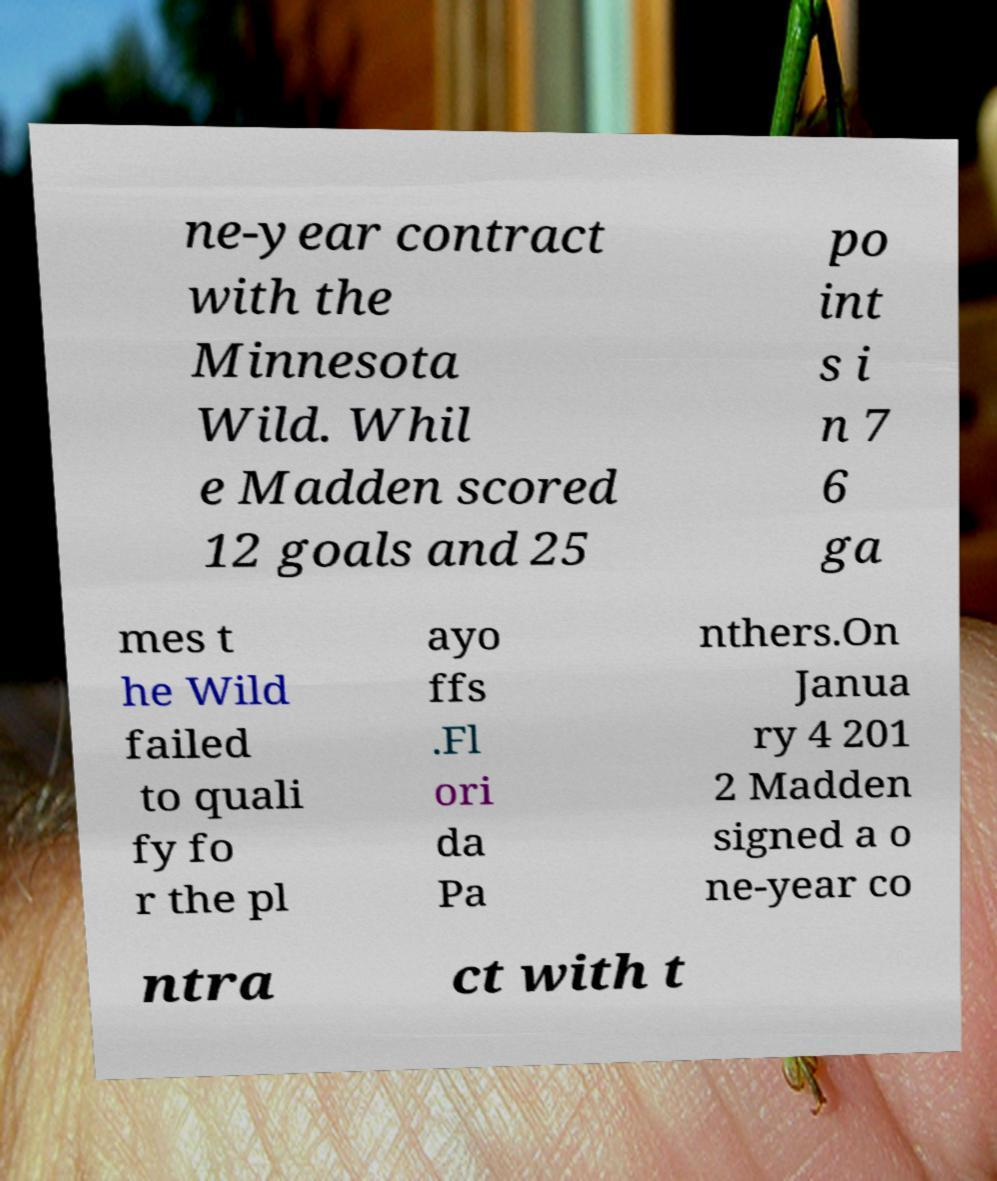There's text embedded in this image that I need extracted. Can you transcribe it verbatim? ne-year contract with the Minnesota Wild. Whil e Madden scored 12 goals and 25 po int s i n 7 6 ga mes t he Wild failed to quali fy fo r the pl ayo ffs .Fl ori da Pa nthers.On Janua ry 4 201 2 Madden signed a o ne-year co ntra ct with t 